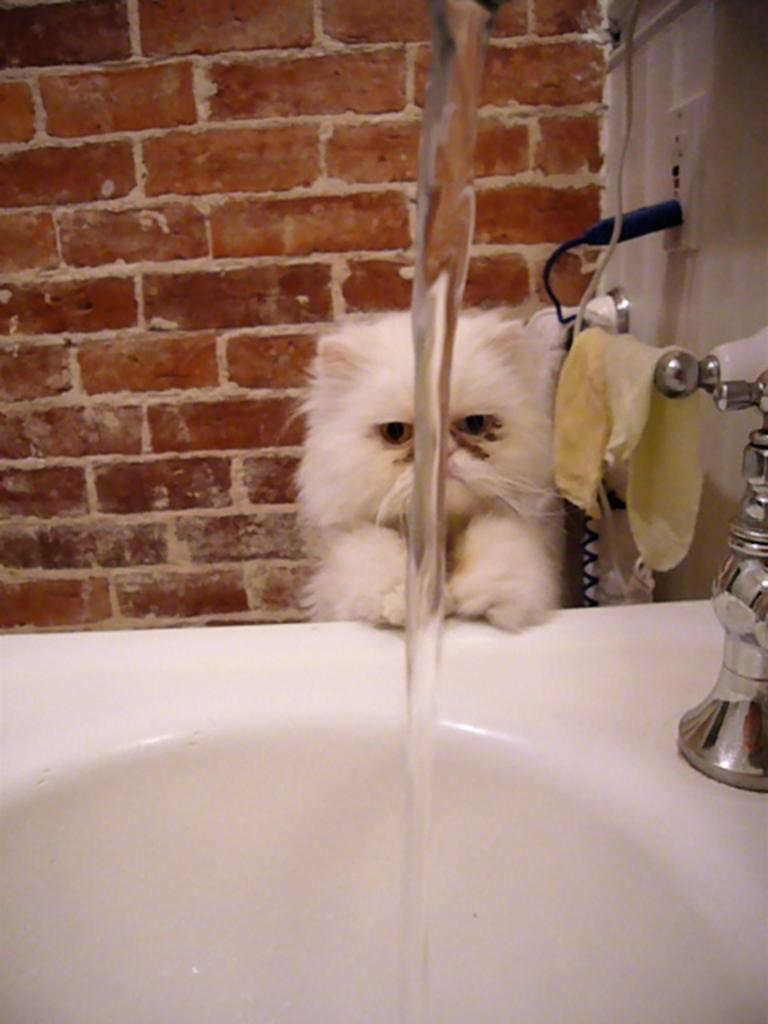What can be seen in the image that is related to water? There is water visible in the image. What type of towel is present in the image? There is a hand towel in the image. What animal is sitting in the image? A cat is sitting on the sink in the image. What position is the wind in the image? There is no wind present in the image. How does the cat express pain in the image? The image does not show the cat expressing pain, as the cat is sitting calmly on the sink. 